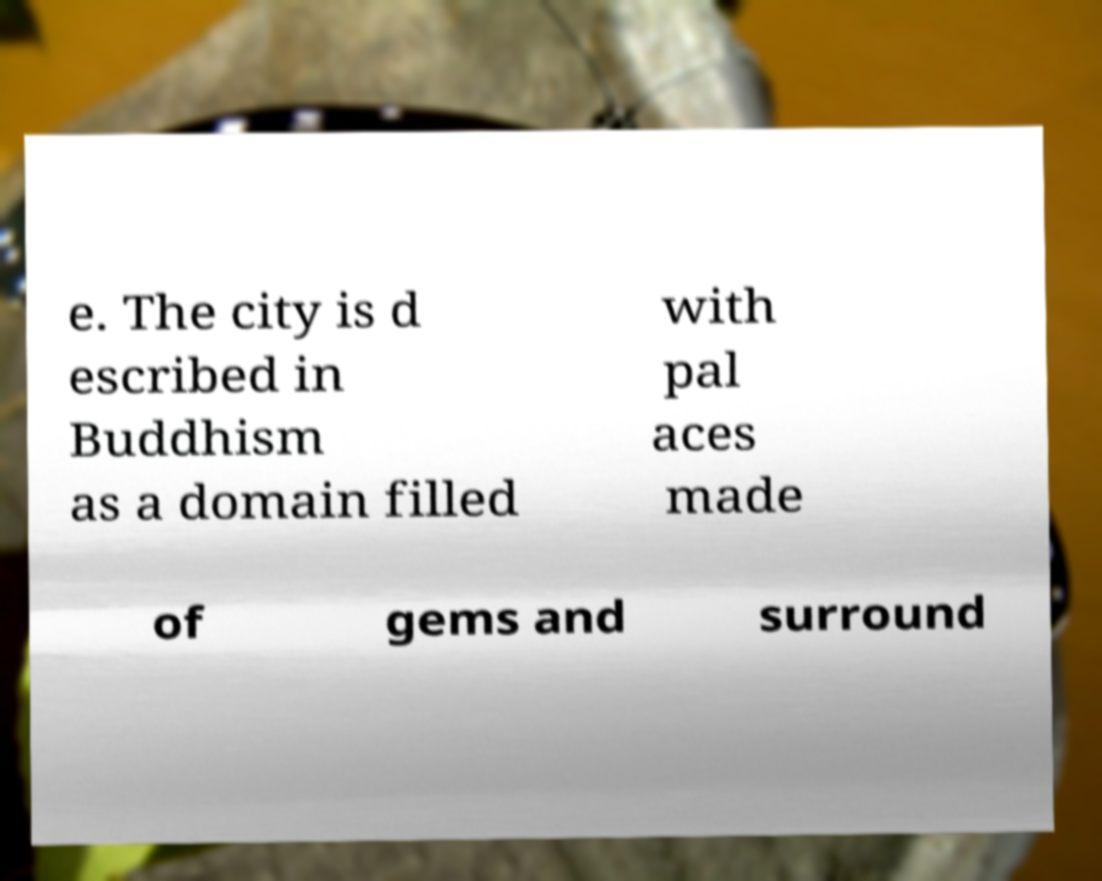Could you extract and type out the text from this image? e. The city is d escribed in Buddhism as a domain filled with pal aces made of gems and surround 